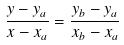Convert formula to latex. <formula><loc_0><loc_0><loc_500><loc_500>\frac { y - y _ { a } } { x - x _ { a } } = \frac { y _ { b } - y _ { a } } { x _ { b } - x _ { a } }</formula> 